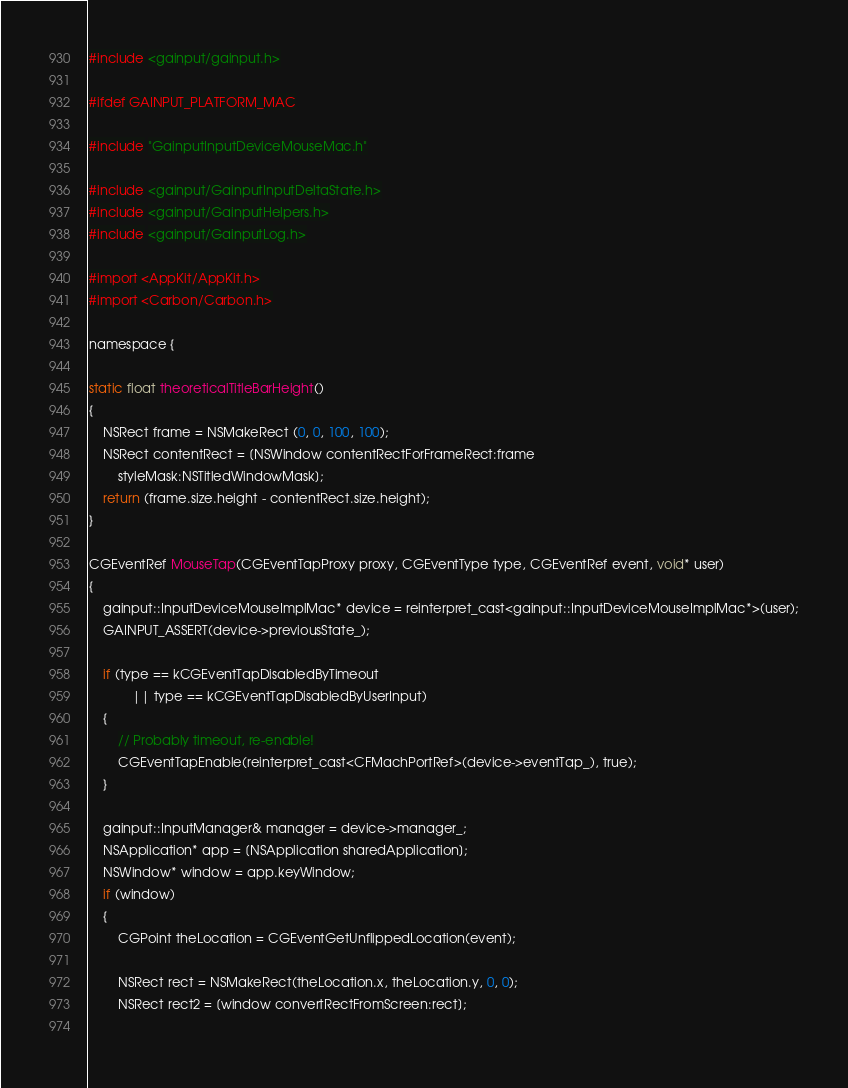Convert code to text. <code><loc_0><loc_0><loc_500><loc_500><_ObjectiveC_>
#include <gainput/gainput.h>

#ifdef GAINPUT_PLATFORM_MAC

#include "GainputInputDeviceMouseMac.h"

#include <gainput/GainputInputDeltaState.h>
#include <gainput/GainputHelpers.h>
#include <gainput/GainputLog.h>

#import <AppKit/AppKit.h>
#import <Carbon/Carbon.h>

namespace {

static float theoreticalTitleBarHeight()
{
	NSRect frame = NSMakeRect (0, 0, 100, 100);
	NSRect contentRect = [NSWindow contentRectForFrameRect:frame
		styleMask:NSTitledWindowMask];
	return (frame.size.height - contentRect.size.height);
}

CGEventRef MouseTap(CGEventTapProxy proxy, CGEventType type, CGEventRef event, void* user)
{
	gainput::InputDeviceMouseImplMac* device = reinterpret_cast<gainput::InputDeviceMouseImplMac*>(user);
	GAINPUT_ASSERT(device->previousState_);

	if (type == kCGEventTapDisabledByTimeout
			|| type == kCGEventTapDisabledByUserInput)
	{
		// Probably timeout, re-enable!
		CGEventTapEnable(reinterpret_cast<CFMachPortRef>(device->eventTap_), true);
	}

    gainput::InputManager& manager = device->manager_;
	NSApplication* app = [NSApplication sharedApplication];
	NSWindow* window = app.keyWindow;
	if (window)
	{
		CGPoint theLocation = CGEventGetUnflippedLocation(event);
        
		NSRect rect = NSMakeRect(theLocation.x, theLocation.y, 0, 0);
		NSRect rect2 = [window convertRectFromScreen:rect];
        </code> 